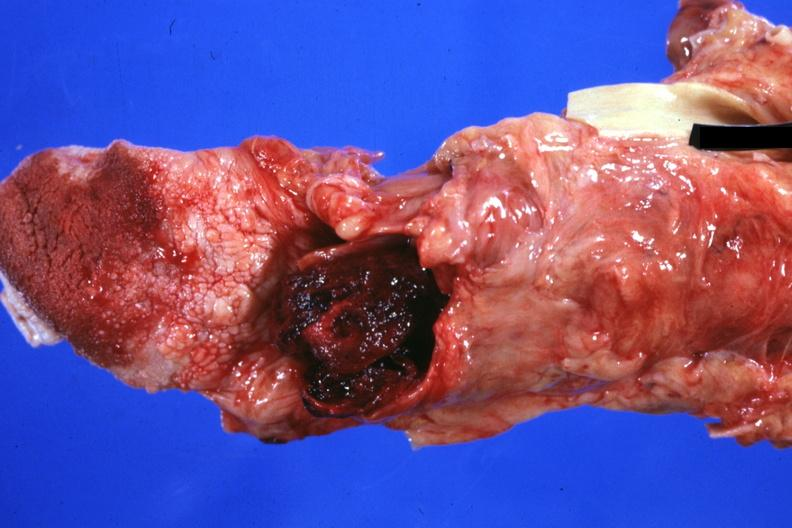where is this?
Answer the question using a single word or phrase. Oral 